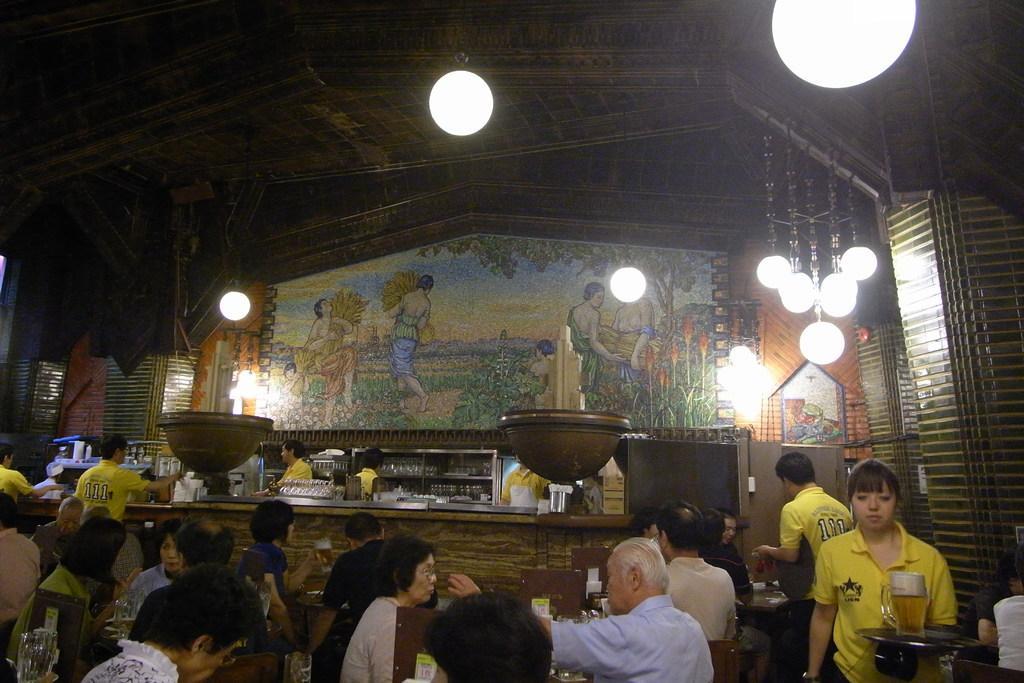Please provide a concise description of this image. The picture is taken in a bar. At the bottom of the picture there are people, tables, jars, glasses, waiters, tray, beer and other objects. In the center of the picture there are glasses, people, boards, bowl like objects and other things. At the top there are lights, painting and ceiling. 